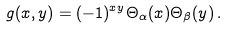<formula> <loc_0><loc_0><loc_500><loc_500>g ( x , y ) = ( - 1 ) ^ { x y } \Theta _ { \alpha } ( x ) \Theta _ { \beta } ( y ) \, .</formula> 